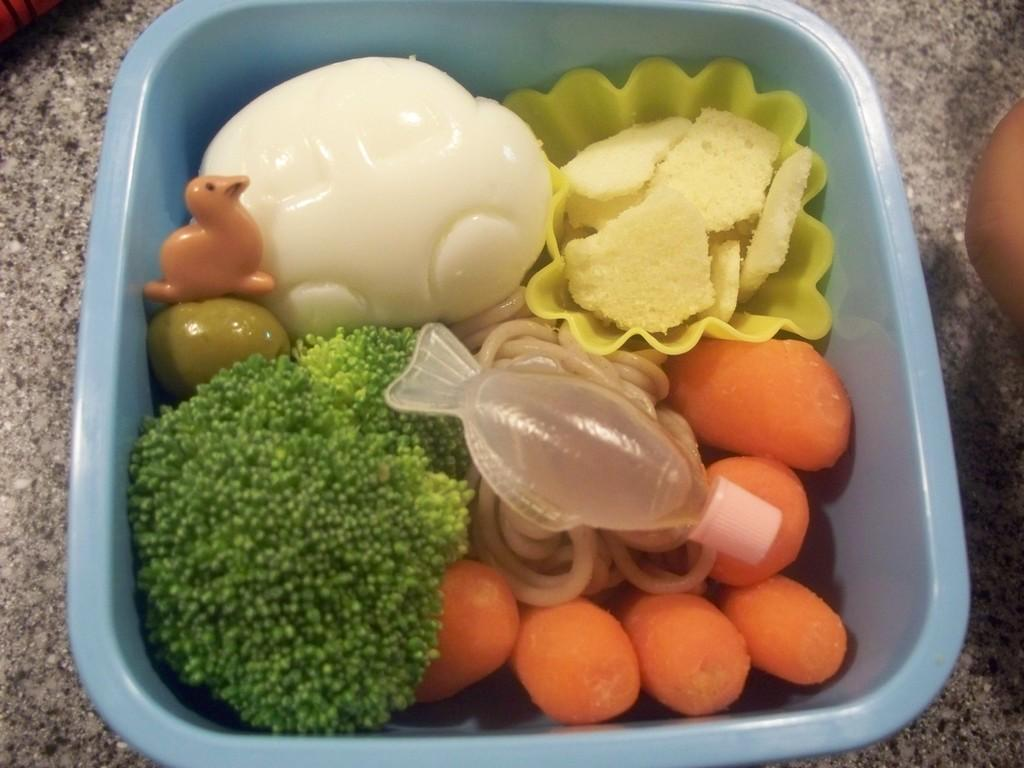What is the color of the bowl in the center of the image? The bowl is blue in color. What is inside the bowl? The bowl contains food items and toys. Can you describe any other objects visible in the background of the image? Unfortunately, the provided facts do not mention any specific objects in the background. What type of crate can be seen in the image? There is no crate present in the image. How do the toys in the bowl smell? The provided facts do not mention any information about the smell of the toys in the bowl. 